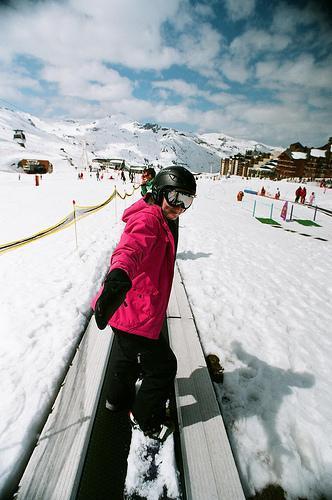How many boots does the woman have on?
Give a very brief answer. 2. 